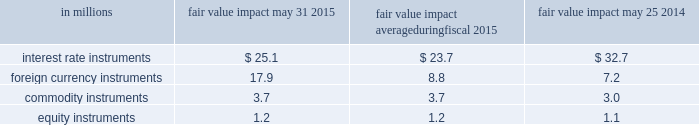Energy ; disruptions or ineffi ciencies in the supply chain ; eff ectiveness of restructuring and cost savings initia- tives ; volatility in the market value of derivatives used to manage price risk for certain commodities ; benefi t plan expenses due to changes in plan asset values and discount rates used to determine plan liabilities ; failure or breach of our information technology systems ; for- eign economic conditions , including currency rate fl uc- tuations ; and political unrest in foreign markets and economic uncertainty due to terrorism or war .
You should also consider the risk factors that we identify in item 1a of our 2015 form 10-k , which could also aff ect our future results .
We undertake no obligation to publicly revise any forward-looking statements to refl ect events or circum- stances aft er the date of those statements or to refl ect the occurrence of anticipated or unanticipated events .
Quantitative and qualitative disclosures about market risk we are exposed to market risk stemming from changes in interest and foreign exchange rates and commod- ity and equity prices .
Changes in these factors could cause fl uctuations in our earnings and cash fl ows .
In the normal course of business , we actively manage our exposure to these market risks by entering into vari- ous hedging transactions , authorized under established policies that place clear controls on these activities .
Th e counterparties in these transactions are generally highly rated institutions .
We establish credit limits for each counterparty .
Our hedging transactions include but are not limited to a variety of derivative fi nancial instruments .
For information on interest rate , foreign exchange , commodity price , and equity instrument risk , please see note 7 to the consolidated financial statements on page 52 of this report .
Value at risk th e estimates in the table below are intended to mea- sure the maximum potential fair value we could lose in one day from adverse changes in market interest rates , foreign exchange rates , commodity prices , and equity prices under normal market conditions .
A monte carlo value-at-risk ( var ) methodology was used to quantify the market risk for our exposures .
Th e models assumed normal market conditions and used a 95 percent confi - dence level .
Th e var calculation used historical interest and for- eign exchange rates , and commodity and equity prices from the past year to estimate the potential volatility and correlation of these rates in the future .
Th e market data were drawn from the riskmetrics 2122 data set .
Th e calculations are not intended to represent actual losses in fair value that we expect to incur .
Further , since the hedging instrument ( the derivative ) inversely correlates with the underlying exposure , we would expect that any loss or gain in the fair value of our derivatives would be generally off set by an increase or decrease in the fair value of the underlying exposure .
Th e positions included in the calculations were : debt ; investments ; interest rate swaps ; foreign exchange forwards ; com- modity swaps , futures and options ; and equity instru- ments .
Th e calculations do not include the underlying foreign exchange and commodities or equity-related positions that are off set by these market-risk-sensitive instruments .
Th e table below presents the estimated maximum potential var arising from a one-day loss in fair value for our interest rate , foreign currency , commodity , and equity market-risk-sensitive instruments outstanding as of may 31 , 2015 , and may 25 , 2014 , and the average fair value impact during the year ended may 31 , 2015. .
36 general mills .
What is the net change in the balance of foreign currency instruments from 2014 to 2015? 
Computations: (17.9 - 7.2)
Answer: 10.7. 